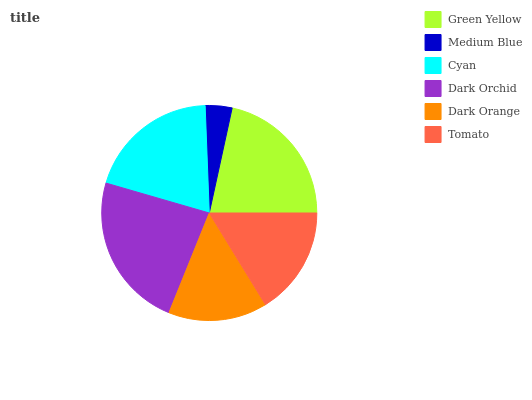Is Medium Blue the minimum?
Answer yes or no. Yes. Is Dark Orchid the maximum?
Answer yes or no. Yes. Is Cyan the minimum?
Answer yes or no. No. Is Cyan the maximum?
Answer yes or no. No. Is Cyan greater than Medium Blue?
Answer yes or no. Yes. Is Medium Blue less than Cyan?
Answer yes or no. Yes. Is Medium Blue greater than Cyan?
Answer yes or no. No. Is Cyan less than Medium Blue?
Answer yes or no. No. Is Cyan the high median?
Answer yes or no. Yes. Is Tomato the low median?
Answer yes or no. Yes. Is Green Yellow the high median?
Answer yes or no. No. Is Dark Orchid the low median?
Answer yes or no. No. 